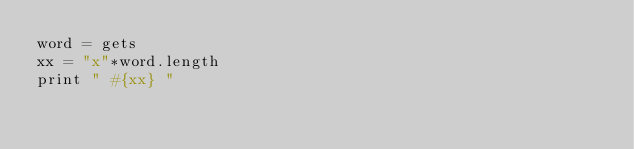<code> <loc_0><loc_0><loc_500><loc_500><_Ruby_>word = gets
xx = "x"*word.length
print " #{xx} "</code> 